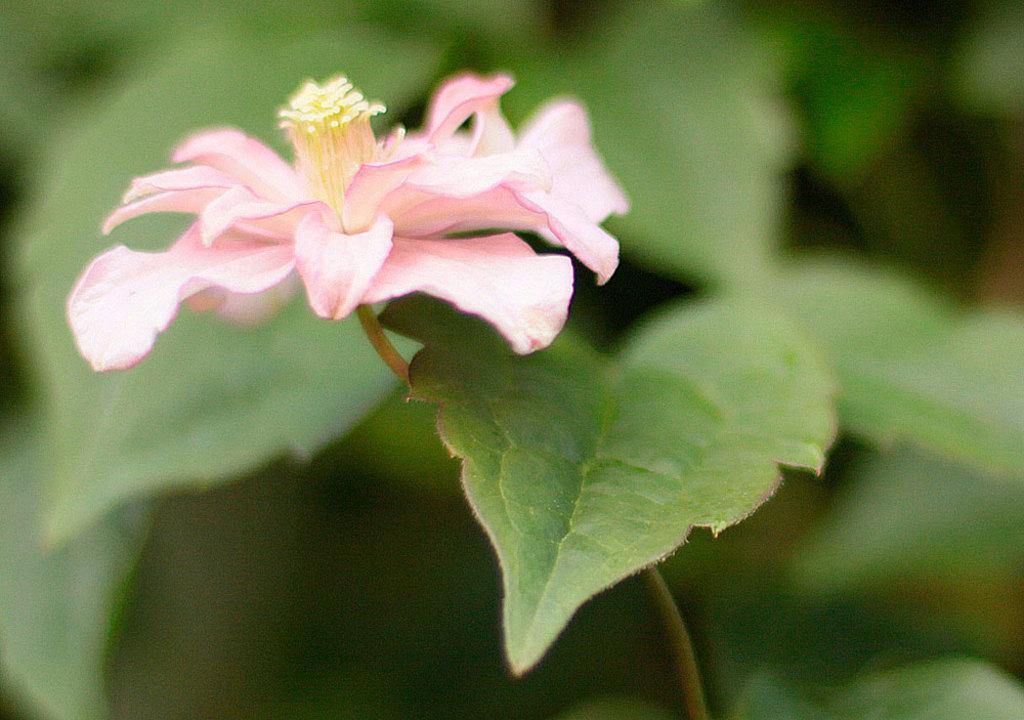Please provide a concise description of this image. In this picture there is a pink color flower and there are green leaves beside it. 